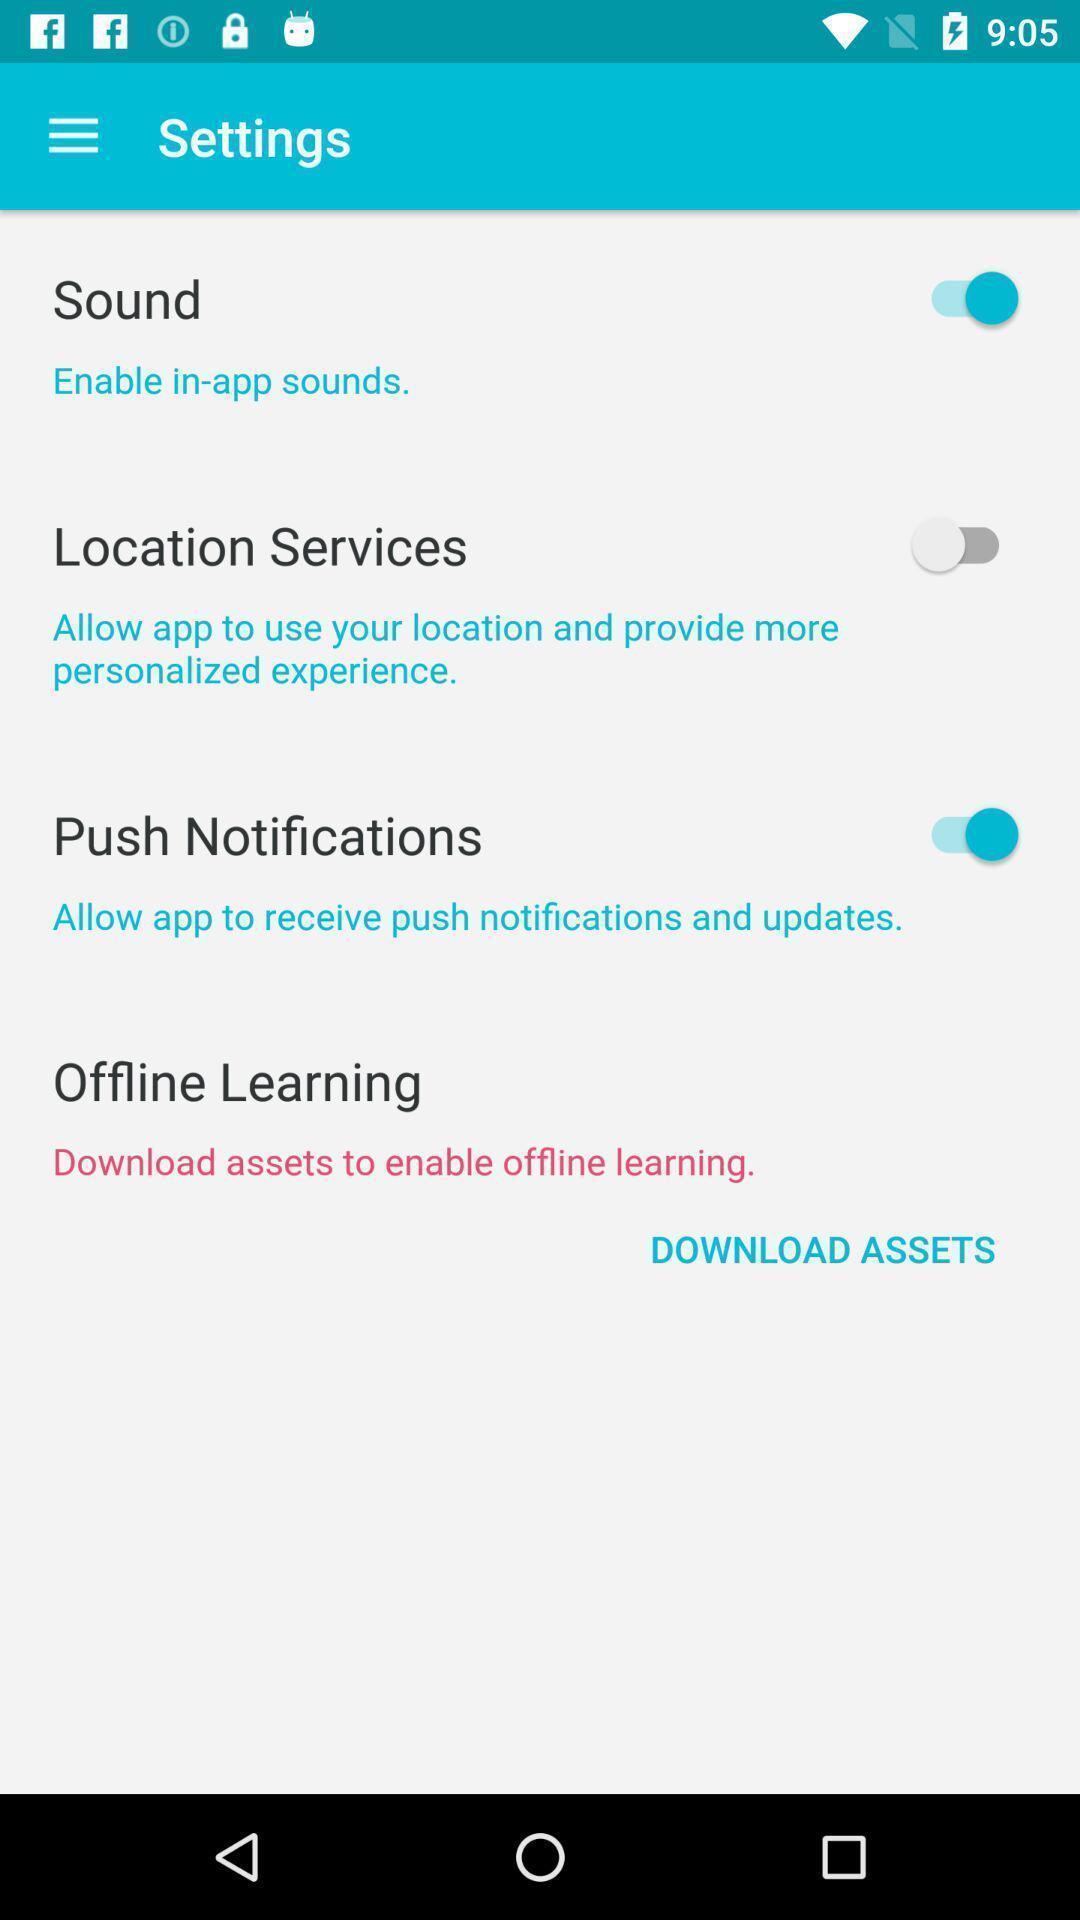Provide a textual representation of this image. Sound settings page. 